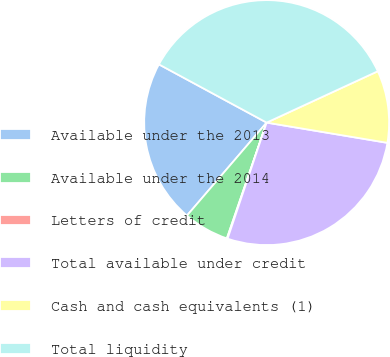Convert chart to OTSL. <chart><loc_0><loc_0><loc_500><loc_500><pie_chart><fcel>Available under the 2013<fcel>Available under the 2014<fcel>Letters of credit<fcel>Total available under credit<fcel>Cash and cash equivalents (1)<fcel>Total liquidity<nl><fcel>21.61%<fcel>6.01%<fcel>0.1%<fcel>27.52%<fcel>9.53%<fcel>35.22%<nl></chart> 